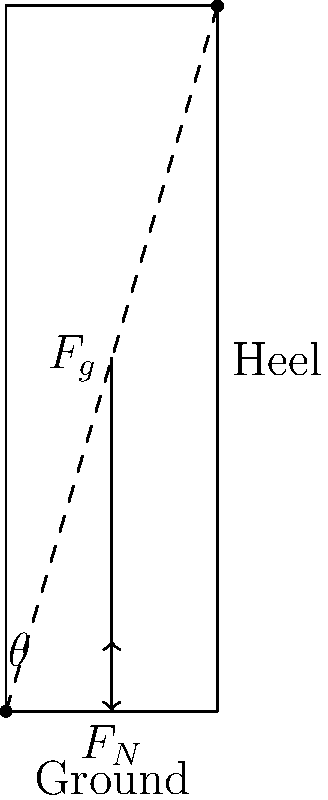As a fashion stylist, you're considering the mechanics of high heels for a photoshoot. A model wearing stilettos exerts a force of 600 N on the ground. If the heel forms a 75° angle with the ground, what is the magnitude of the normal force acting on the heel? Assume the heel is perfectly rigid and ignore any other forces. Let's approach this step-by-step:

1) First, we need to understand the forces at play:
   - The gravitational force ($F_g$) acts downward, which is 600 N.
   - The normal force ($F_N$) acts perpendicular to the surface of the heel.

2) We can use the concept of force resolution to solve this problem. The normal force will be equal to the component of the gravitational force that's perpendicular to the heel.

3) Given:
   - $F_g = 600$ N
   - Angle between heel and ground = 75°

4) The angle between the heel and the normal force is 90° - 75° = 15°

5) We can use the cosine function to find the normal force:

   $F_N = F_g \cdot \cos(15°)$

6) Let's calculate:
   $F_N = 600 \cdot \cos(15°)$
   $F_N = 600 \cdot 0.9659$
   $F_N \approx 579.54$ N

7) Rounding to the nearest whole number:
   $F_N \approx 580$ N

Thus, the magnitude of the normal force acting on the heel is approximately 580 N.
Answer: 580 N 